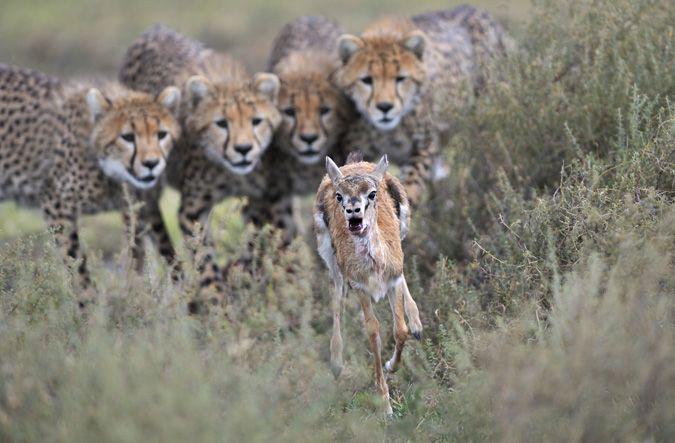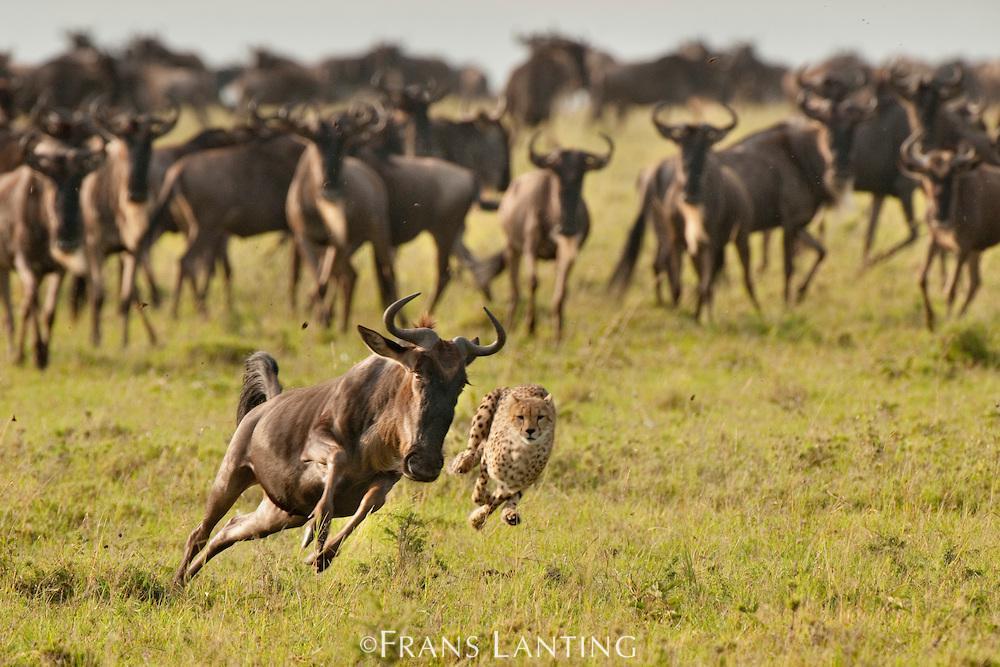The first image is the image on the left, the second image is the image on the right. Given the left and right images, does the statement "An image shows a back-turned cheetah running toward a herd of fleeing horned animals, which are kicking up clouds of dust." hold true? Answer yes or no. No. 